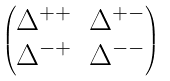<formula> <loc_0><loc_0><loc_500><loc_500>\begin{pmatrix} \Delta ^ { + + } & \Delta ^ { + - } \\ \Delta ^ { - + } & \Delta ^ { - - } \\ \end{pmatrix}</formula> 